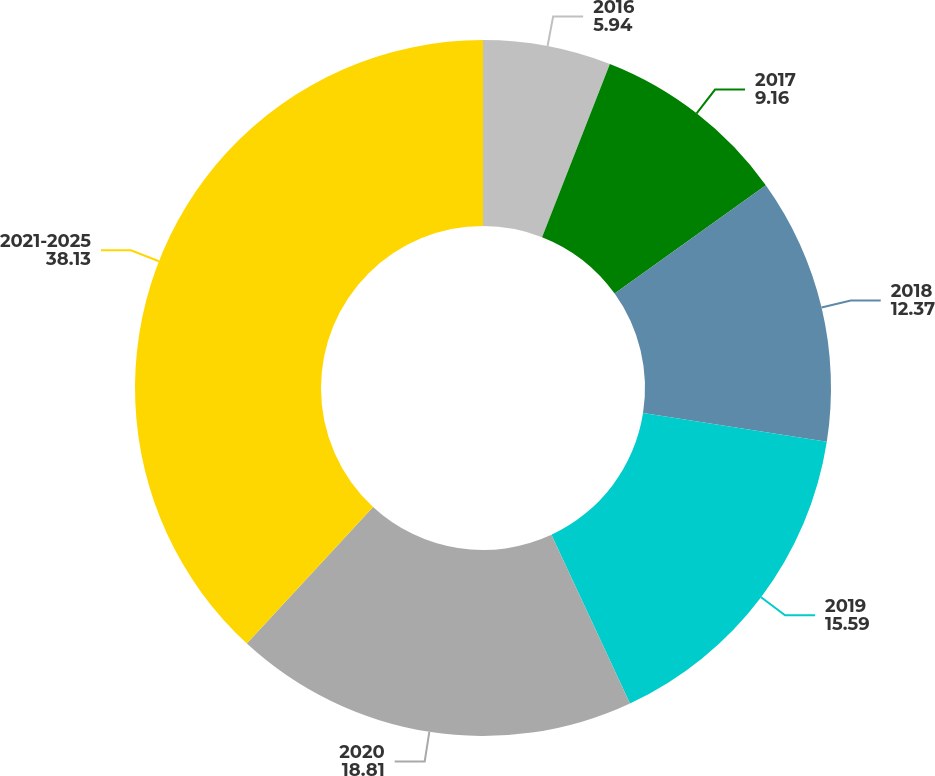Convert chart. <chart><loc_0><loc_0><loc_500><loc_500><pie_chart><fcel>2016<fcel>2017<fcel>2018<fcel>2019<fcel>2020<fcel>2021-2025<nl><fcel>5.94%<fcel>9.16%<fcel>12.37%<fcel>15.59%<fcel>18.81%<fcel>38.13%<nl></chart> 